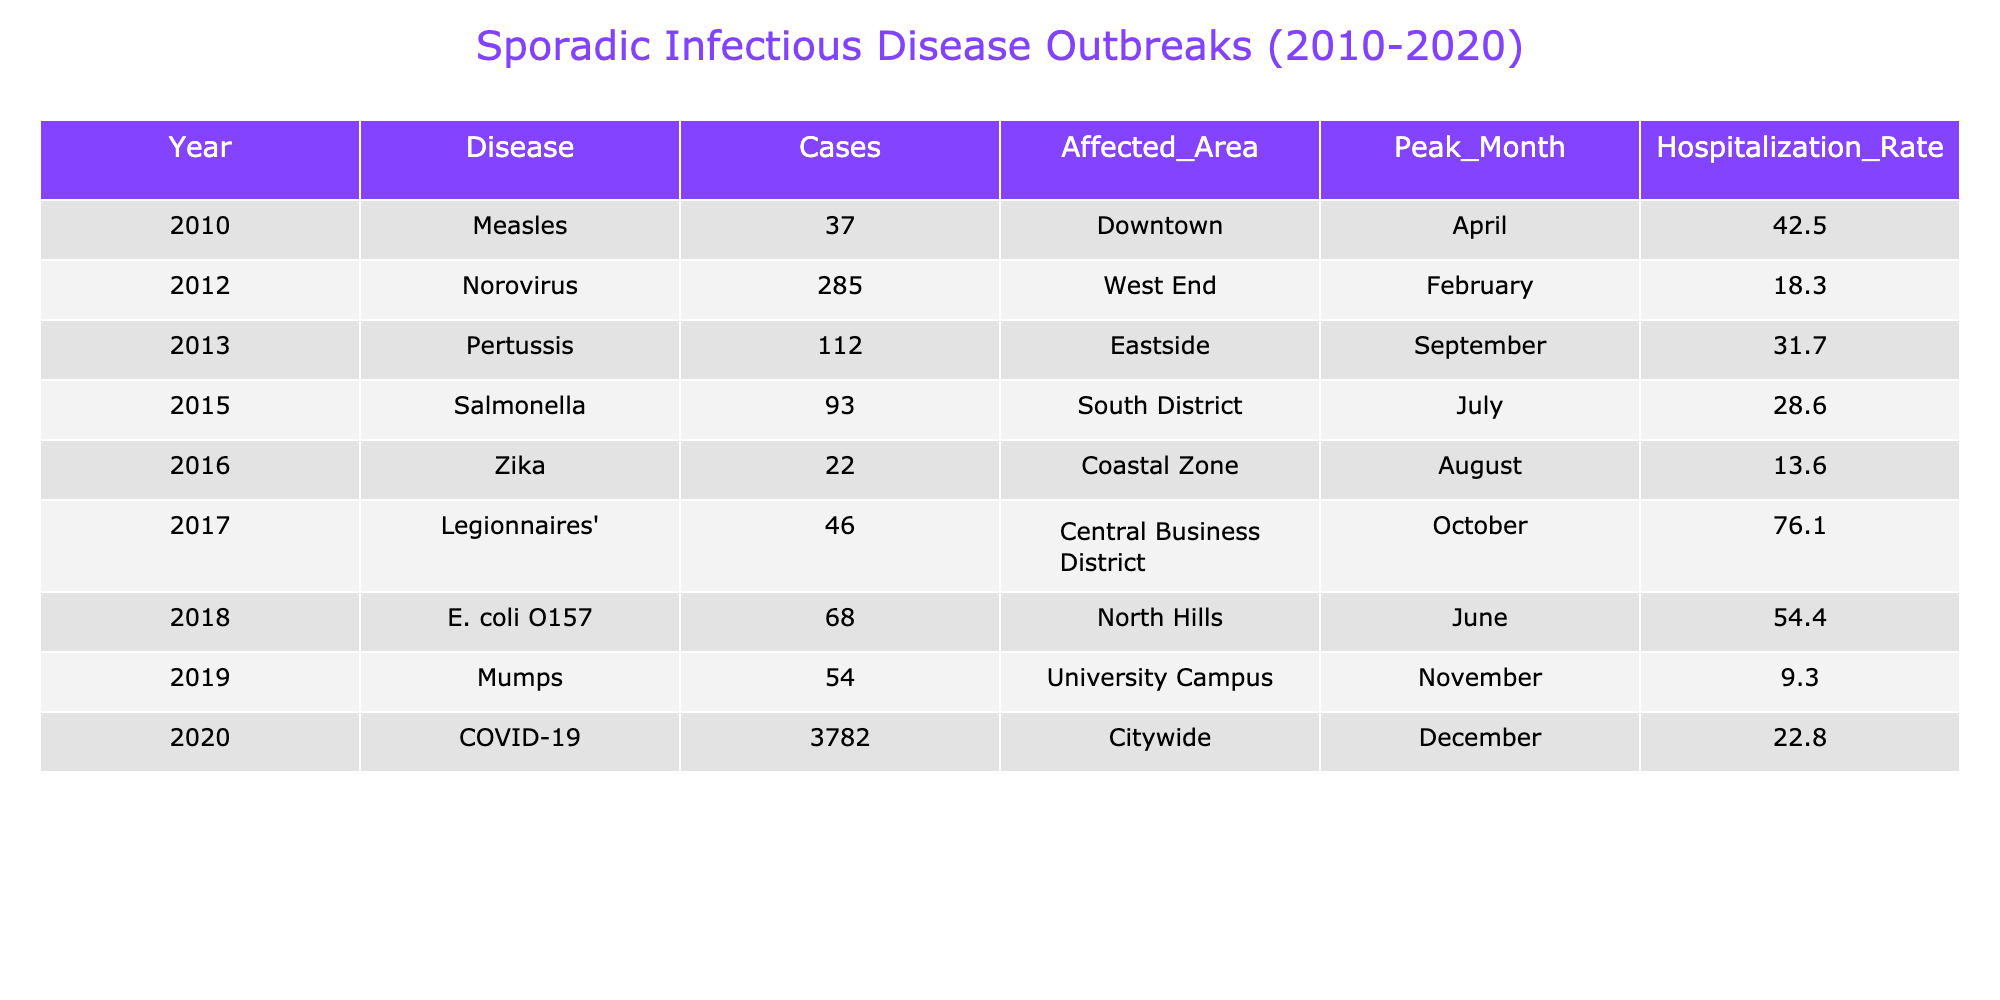What was the peak month for Zika outbreaks? The table lists Zika under the year 2016, with the peak month specified as August.
Answer: August How many cases of Mumps were reported in 2019? The table shows that there were 54 cases of Mumps reported in the year 2019.
Answer: 54 What is the hospitalization rate for Norovirus in 2012? The table indicates that the hospitalization rate for Norovirus in 2012 was 18.3%.
Answer: 18.3% Which disease had the highest number of reported cases? By examining the "Cases" column, COVID-19 in 2020 had the highest number of cases, totaling 3782 cases.
Answer: COVID-19 How many cases of Measles and Pertussis were combined? Adding the cases of Measles (37) and Pertussis (112) gives a total of 149 cases (37 + 112 = 149).
Answer: 149 Which area reported the highest hospitalization rate, and what was that rate? From the table, Legionnaires' in the Central Business District had the highest hospitalization rate of 76.1%.
Answer: 76.1% Is the hospitalization rate for E. coli O157 higher than that of Zika? The hospitalization rate for E. coli O157 is 54.4% and for Zika is 13.6%. Since 54.4% is greater than 13.6%, the statement is true.
Answer: Yes What was the average number of cases across all diseases from 2010 to 2020? Summing the cases (37 + 285 + 112 + 93 + 22 + 46 + 68 + 54 + 3782) gives 4357. Dividing by the number of outbreaks (9) results in an average of approximately 484.11 cases (4357/9 ≈ 484.11).
Answer: Approximately 484.11 How many diseases reported hospitalizations rates below 20%? The table lists Zika (13.6%) and Mumps (9.3%) as having hospitalization rates below 20%. Thus, there are 2 diseases.
Answer: 2 What is the difference in cases between Salmonella and E. coli O157? Salmonella reported 93 cases and E. coli O157 reported 68 cases. The difference is 25 cases (93 - 68 = 25).
Answer: 25 In which year did the highest number of diseases occur, and how many were reported that year? In 2020, there was a high outbreak of COVID-19 with 3782 cases. It is the year with the highest number of cases reported, which is one disease.
Answer: 2020, 1 disease 